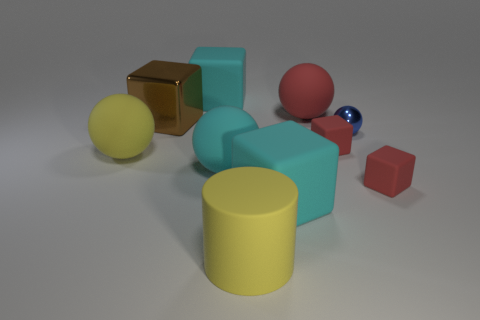Subtract all brown blocks. How many blocks are left? 4 Subtract all brown metal blocks. How many blocks are left? 4 Subtract all blue cubes. Subtract all cyan cylinders. How many cubes are left? 5 Subtract all spheres. How many objects are left? 6 Add 7 tiny metal blocks. How many tiny metal blocks exist? 7 Subtract 0 green blocks. How many objects are left? 10 Subtract all tiny red things. Subtract all shiny objects. How many objects are left? 6 Add 4 large cyan balls. How many large cyan balls are left? 5 